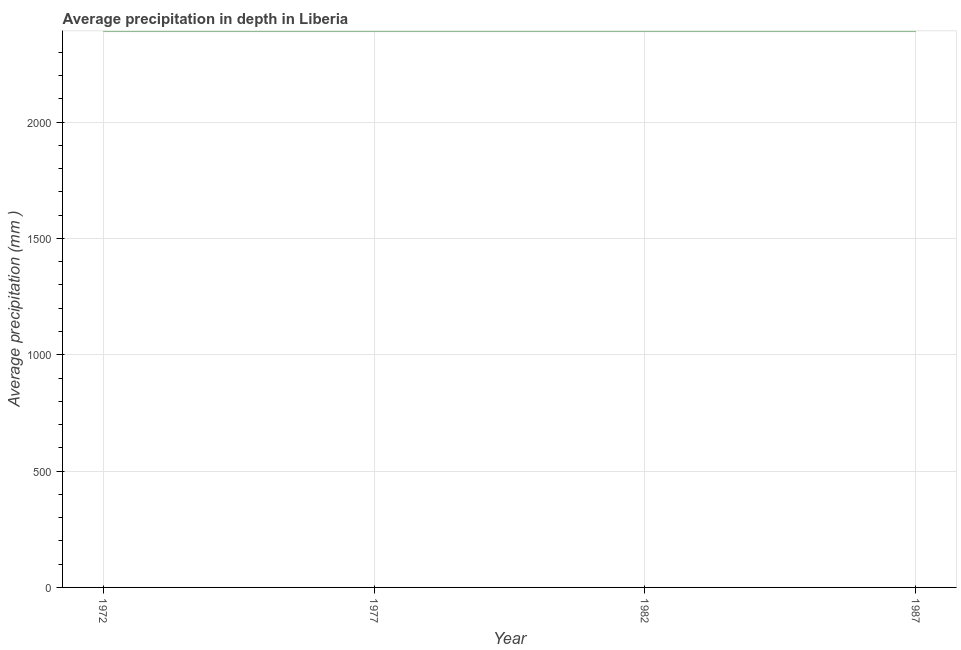What is the average precipitation in depth in 1987?
Offer a very short reply. 2391. Across all years, what is the maximum average precipitation in depth?
Your answer should be very brief. 2391. Across all years, what is the minimum average precipitation in depth?
Your answer should be very brief. 2391. In which year was the average precipitation in depth minimum?
Make the answer very short. 1972. What is the sum of the average precipitation in depth?
Make the answer very short. 9564. What is the average average precipitation in depth per year?
Provide a succinct answer. 2391. What is the median average precipitation in depth?
Your answer should be very brief. 2391. What is the ratio of the average precipitation in depth in 1972 to that in 1982?
Provide a short and direct response. 1. Is the difference between the average precipitation in depth in 1972 and 1982 greater than the difference between any two years?
Give a very brief answer. Yes. What is the difference between the highest and the second highest average precipitation in depth?
Give a very brief answer. 0. Is the sum of the average precipitation in depth in 1972 and 1977 greater than the maximum average precipitation in depth across all years?
Keep it short and to the point. Yes. In how many years, is the average precipitation in depth greater than the average average precipitation in depth taken over all years?
Your response must be concise. 0. How many lines are there?
Offer a terse response. 1. Are the values on the major ticks of Y-axis written in scientific E-notation?
Offer a terse response. No. What is the title of the graph?
Offer a very short reply. Average precipitation in depth in Liberia. What is the label or title of the X-axis?
Your answer should be very brief. Year. What is the label or title of the Y-axis?
Make the answer very short. Average precipitation (mm ). What is the Average precipitation (mm ) of 1972?
Make the answer very short. 2391. What is the Average precipitation (mm ) of 1977?
Your answer should be very brief. 2391. What is the Average precipitation (mm ) in 1982?
Your answer should be very brief. 2391. What is the Average precipitation (mm ) of 1987?
Offer a very short reply. 2391. What is the difference between the Average precipitation (mm ) in 1977 and 1982?
Your response must be concise. 0. What is the difference between the Average precipitation (mm ) in 1977 and 1987?
Your answer should be very brief. 0. What is the difference between the Average precipitation (mm ) in 1982 and 1987?
Make the answer very short. 0. What is the ratio of the Average precipitation (mm ) in 1972 to that in 1977?
Provide a short and direct response. 1. What is the ratio of the Average precipitation (mm ) in 1972 to that in 1987?
Keep it short and to the point. 1. What is the ratio of the Average precipitation (mm ) in 1977 to that in 1987?
Keep it short and to the point. 1. 